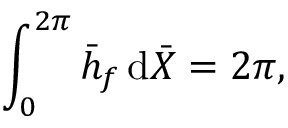<formula> <loc_0><loc_0><loc_500><loc_500>\int _ { 0 } ^ { 2 \pi } \bar { h } _ { f } \, d \bar { X } = 2 \pi ,</formula> 